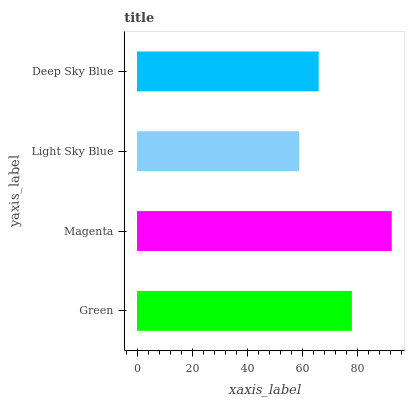Is Light Sky Blue the minimum?
Answer yes or no. Yes. Is Magenta the maximum?
Answer yes or no. Yes. Is Magenta the minimum?
Answer yes or no. No. Is Light Sky Blue the maximum?
Answer yes or no. No. Is Magenta greater than Light Sky Blue?
Answer yes or no. Yes. Is Light Sky Blue less than Magenta?
Answer yes or no. Yes. Is Light Sky Blue greater than Magenta?
Answer yes or no. No. Is Magenta less than Light Sky Blue?
Answer yes or no. No. Is Green the high median?
Answer yes or no. Yes. Is Deep Sky Blue the low median?
Answer yes or no. Yes. Is Light Sky Blue the high median?
Answer yes or no. No. Is Light Sky Blue the low median?
Answer yes or no. No. 